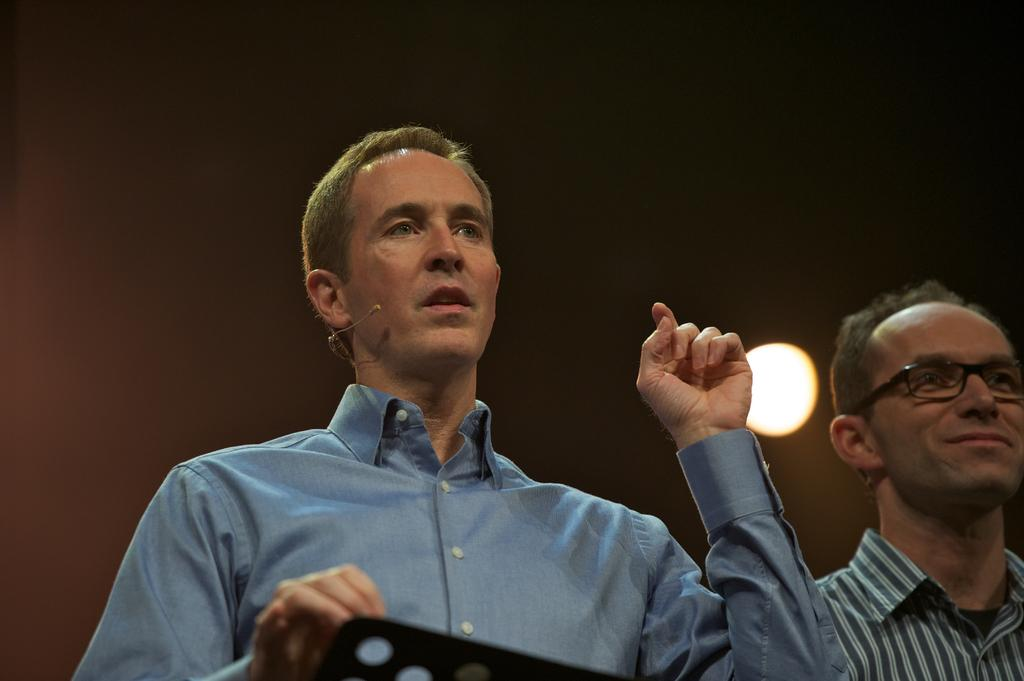What is the person in the image wearing? The person in the image is wearing a shirt. What is located in front of the person? There is an object before the person. Can you describe the other person in the image? There is a person wearing spectacles beside the first person. What is attached to the wall behind the two people? There is a light attached to the wall behind the two people. What type of fiction is the person offering to the other person in the image? There is no indication of any fiction or offering in the image; it only shows two people and an object. 